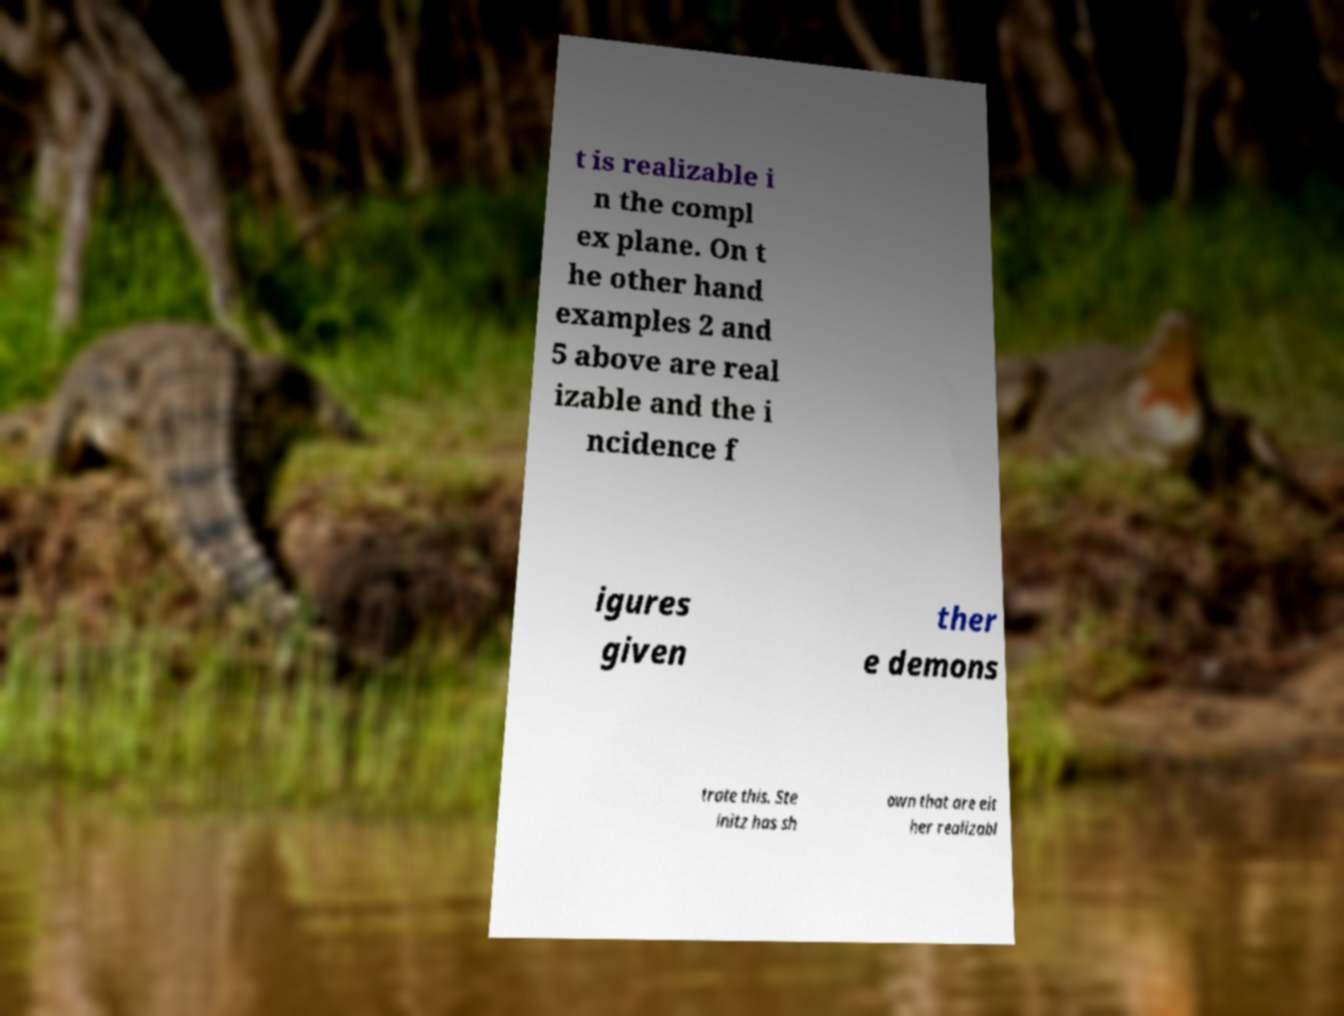Can you accurately transcribe the text from the provided image for me? t is realizable i n the compl ex plane. On t he other hand examples 2 and 5 above are real izable and the i ncidence f igures given ther e demons trate this. Ste initz has sh own that are eit her realizabl 